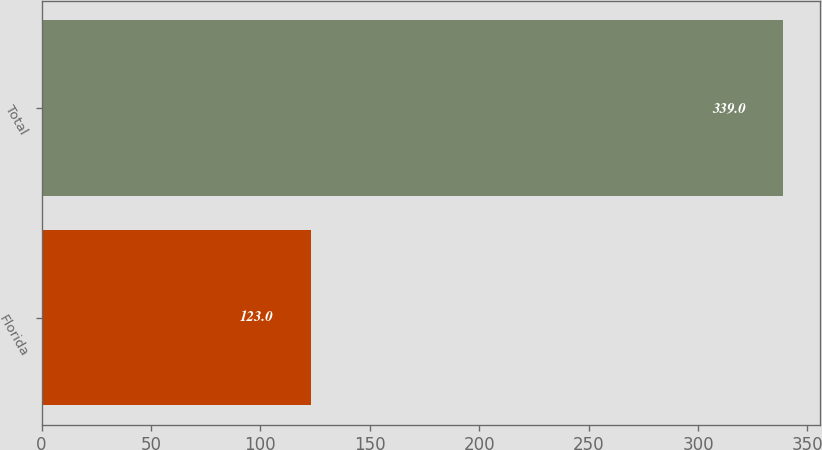Convert chart. <chart><loc_0><loc_0><loc_500><loc_500><bar_chart><fcel>Florida<fcel>Total<nl><fcel>123<fcel>339<nl></chart> 